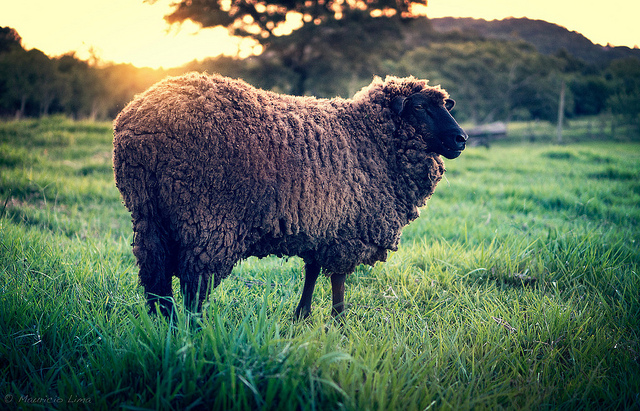Imagine the story of this sheep. Why is it alone in this field? Imagine this sheep, named Woolly, is the leader of its flock. Today, Woolly is standing alone in the field, keeping watch while the rest of the flock grazes nearby, just out of the frame. Woolly enjoys the solitude and the gentle warmth of the sun as it prepares to lead its friends to a new, greener pasture. 